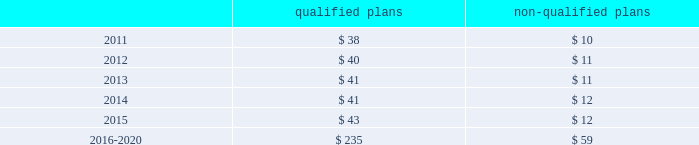Employee retirement plans 2013 ( continued ) of equities and fixed-income investments , and would be less liquid than financial instruments that trade on public markets .
Potential events or circumstances that could have a negative effect on estimated fair value include the risks of inadequate diversification and other operating risks .
To mitigate these risks , investments are diversified across and within asset classes in support of investment objectives .
Policies and practices to address operating risks include ongoing manager oversight , plan and asset class investment guidelines and instructions that are communicated to managers , and periodic compliance and audit reviews to ensure adherence to these policies .
In addition , the company periodically seeks the input of its independent advisor to ensure the investment policy is appropriate .
The company sponsors certain post-retirement benefit plans that provide medical , dental and life insurance coverage for eligible retirees and dependents in the united states based upon age and length of service .
The aggregate present value of the unfunded accumulated post-retirement benefit obligation was $ 13 million at both december 31 , 2010 and 2009 .
Cash flows at december 31 , 2010 , the company expected to contribute approximately $ 30 million to $ 35 million to its qualified defined-benefit pension plans to meet erisa requirements in 2011 .
The company also expected to pay benefits of $ 3 million and $ 10 million to participants of its unfunded foreign and non-qualified ( domestic ) defined-benefit pension plans , respectively , in 2011 .
At december 31 , 2010 , the benefits expected to be paid in each of the next five years , and in aggregate for the five years thereafter , relating to the company 2019s defined-benefit pension plans , were as follows , in millions : qualified non-qualified .
Shareholders 2019 equity in july 2007 , the company 2019s board of directors authorized the repurchase for retirement of up to 50 million shares of the company 2019s common stock in open-market transactions or otherwise .
At december 31 , 2010 , the company had remaining authorization to repurchase up to 27 million shares .
During 2010 , the company repurchased and retired three million shares of company common stock , for cash aggregating $ 45 million to offset the dilutive impact of the 2010 grant of three million shares of long-term stock awards .
The company repurchased and retired two million common shares in 2009 and nine million common shares in 2008 for cash aggregating $ 11 million and $ 160 million in 2009 and 2008 , respectively .
On the basis of amounts paid ( declared ) , cash dividends per common share were $ .30 ( $ .30 ) in 2010 , $ .46 ( $ .30 ) in 2009 and $ .925 ( $ .93 ) in 2008 , respectively .
In 2009 , the company decreased its quarterly cash dividend to $ .075 per common share from $ .235 per common share .
Masco corporation notes to consolidated financial statements 2014 ( continued ) .
At december 31 , 2010 what was the percent of the shares remaining authorization to repurchase of the amount authorization by the board in 2007? 
Rationale: at december 31 , 2010 54% of the shares were remaining of the amount authorized to repurchase in 2007
Computations: (27 / 50)
Answer: 0.54. 